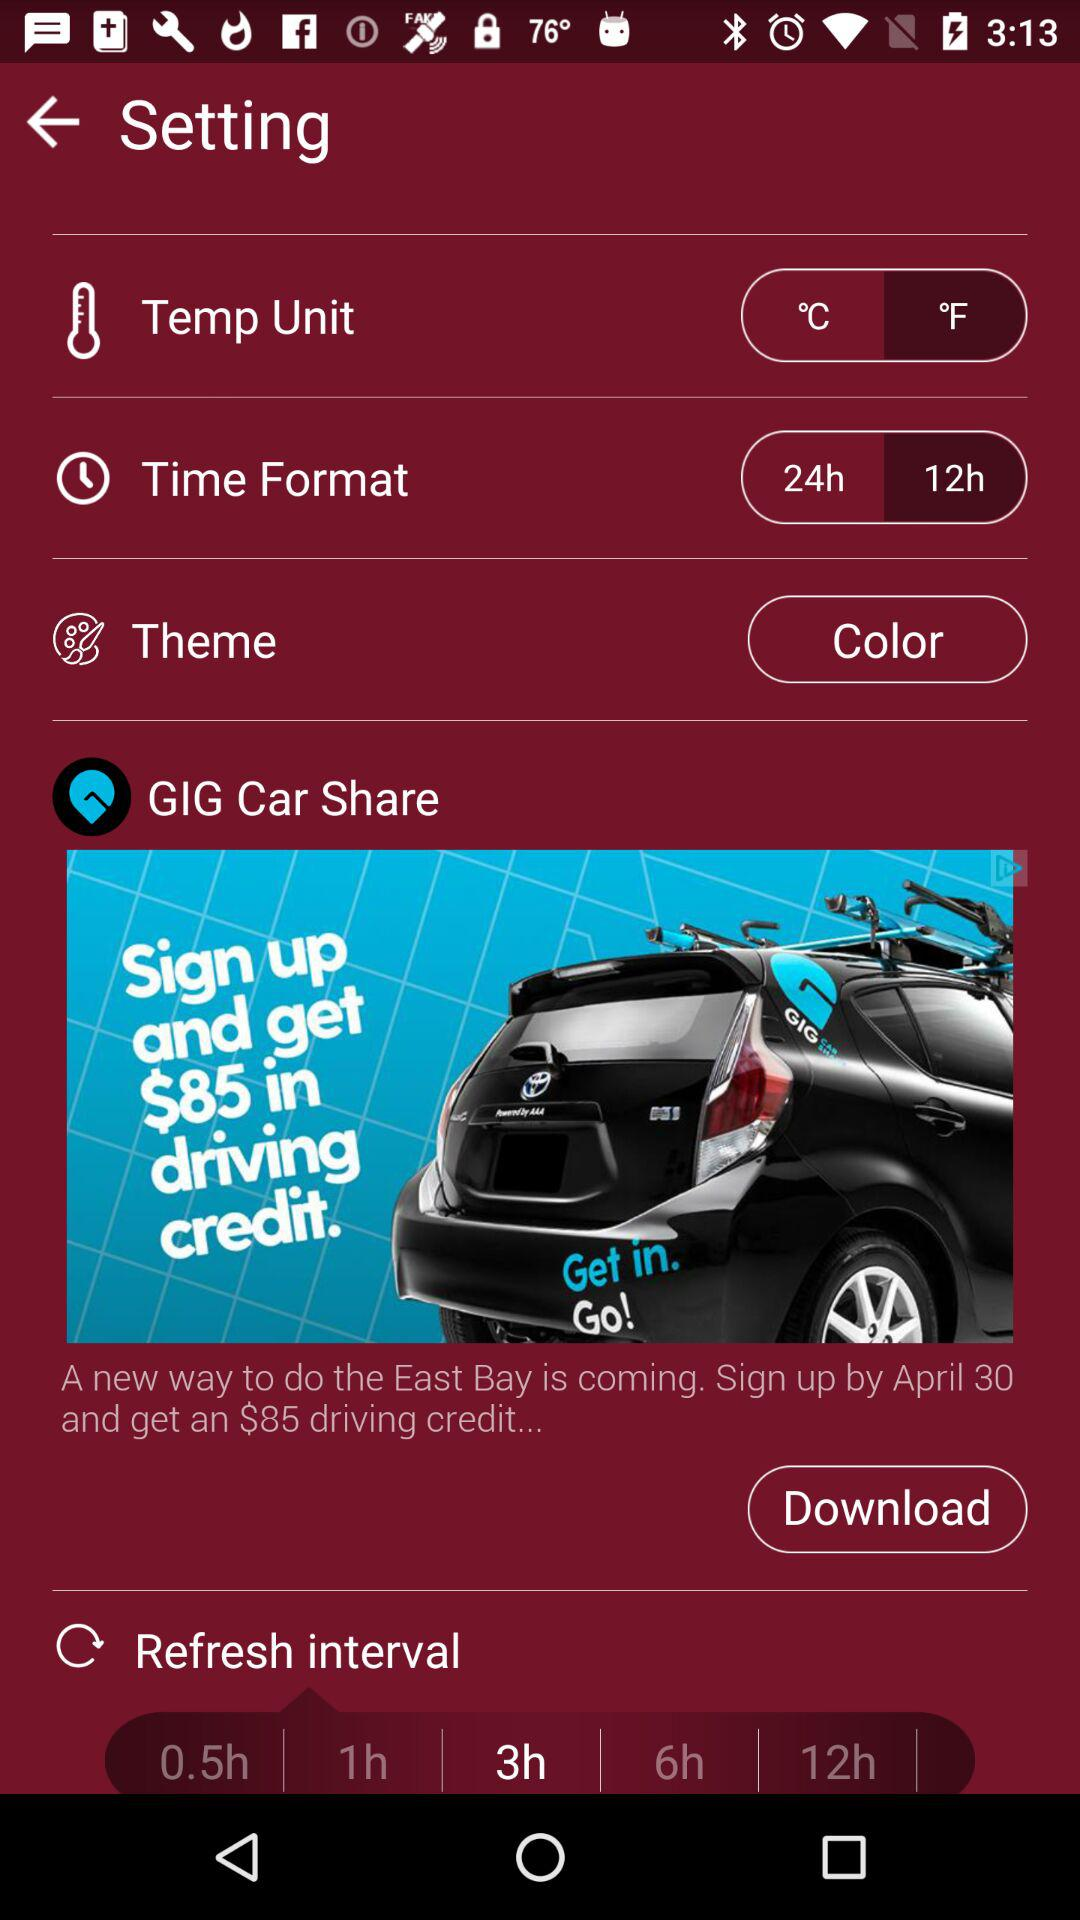What is the selected temperature unit? The selected temperature unit is "°F". 